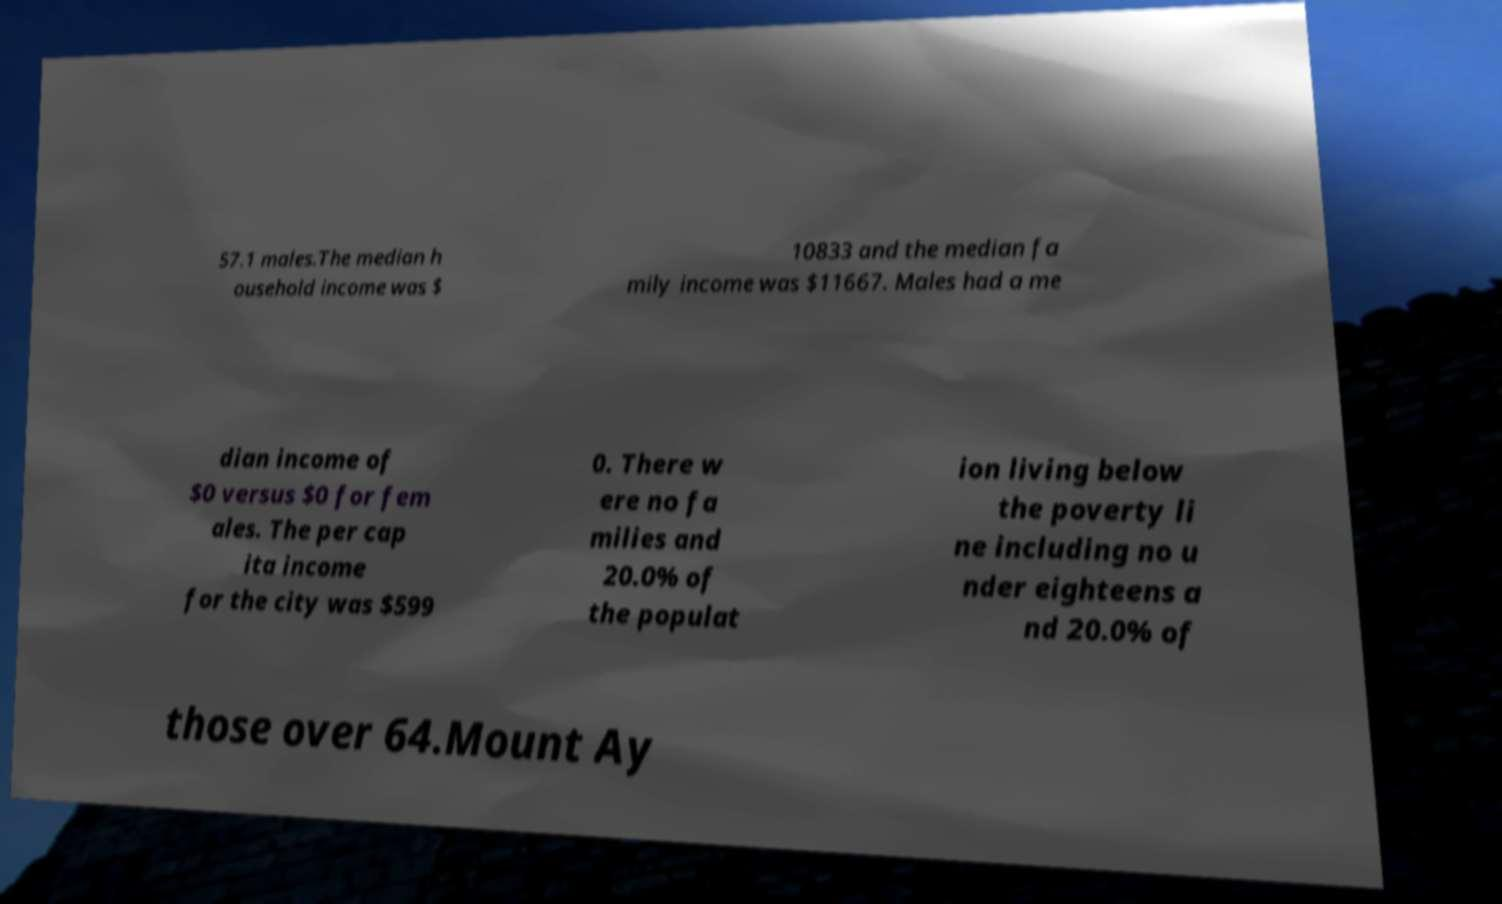I need the written content from this picture converted into text. Can you do that? 57.1 males.The median h ousehold income was $ 10833 and the median fa mily income was $11667. Males had a me dian income of $0 versus $0 for fem ales. The per cap ita income for the city was $599 0. There w ere no fa milies and 20.0% of the populat ion living below the poverty li ne including no u nder eighteens a nd 20.0% of those over 64.Mount Ay 